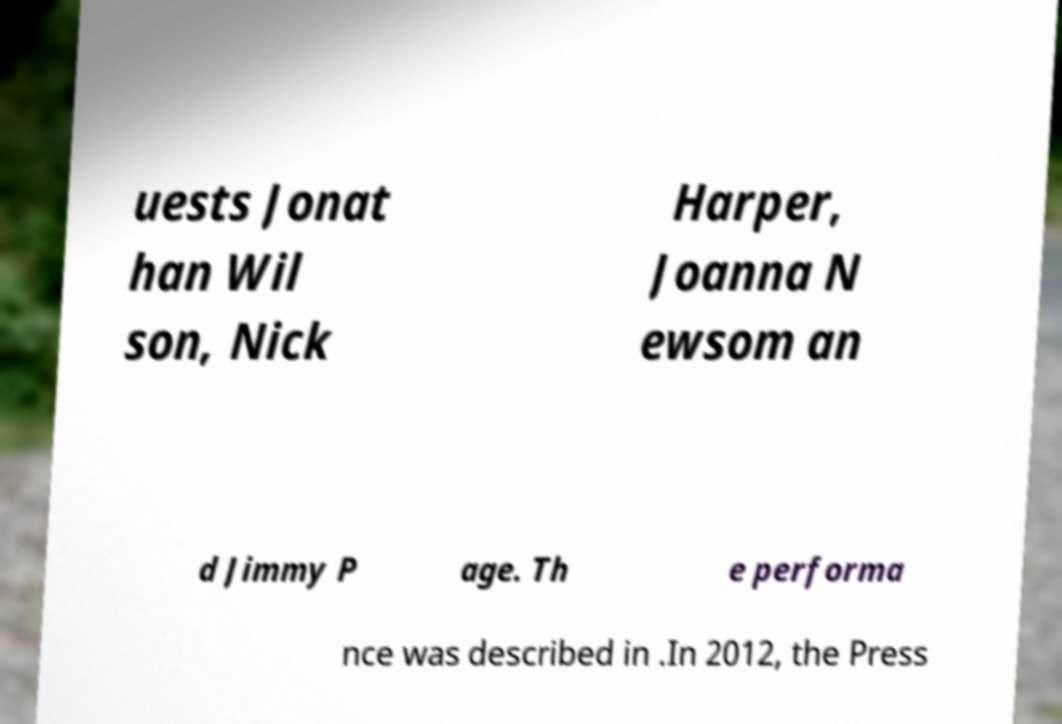There's text embedded in this image that I need extracted. Can you transcribe it verbatim? uests Jonat han Wil son, Nick Harper, Joanna N ewsom an d Jimmy P age. Th e performa nce was described in .In 2012, the Press 